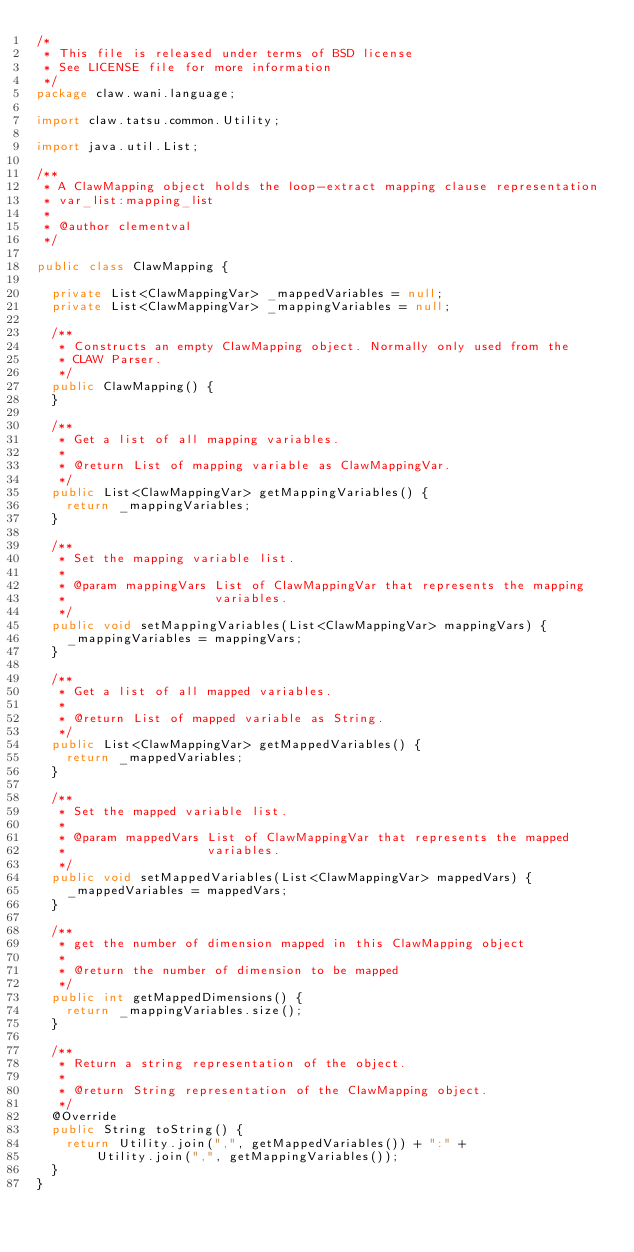Convert code to text. <code><loc_0><loc_0><loc_500><loc_500><_Java_>/*
 * This file is released under terms of BSD license
 * See LICENSE file for more information
 */
package claw.wani.language;

import claw.tatsu.common.Utility;

import java.util.List;

/**
 * A ClawMapping object holds the loop-extract mapping clause representation
 * var_list:mapping_list
 *
 * @author clementval
 */

public class ClawMapping {

  private List<ClawMappingVar> _mappedVariables = null;
  private List<ClawMappingVar> _mappingVariables = null;

  /**
   * Constructs an empty ClawMapping object. Normally only used from the
   * CLAW Parser.
   */
  public ClawMapping() {
  }

  /**
   * Get a list of all mapping variables.
   *
   * @return List of mapping variable as ClawMappingVar.
   */
  public List<ClawMappingVar> getMappingVariables() {
    return _mappingVariables;
  }

  /**
   * Set the mapping variable list.
   *
   * @param mappingVars List of ClawMappingVar that represents the mapping
   *                    variables.
   */
  public void setMappingVariables(List<ClawMappingVar> mappingVars) {
    _mappingVariables = mappingVars;
  }

  /**
   * Get a list of all mapped variables.
   *
   * @return List of mapped variable as String.
   */
  public List<ClawMappingVar> getMappedVariables() {
    return _mappedVariables;
  }

  /**
   * Set the mapped variable list.
   *
   * @param mappedVars List of ClawMappingVar that represents the mapped
   *                   variables.
   */
  public void setMappedVariables(List<ClawMappingVar> mappedVars) {
    _mappedVariables = mappedVars;
  }

  /**
   * get the number of dimension mapped in this ClawMapping object
   *
   * @return the number of dimension to be mapped
   */
  public int getMappedDimensions() {
    return _mappingVariables.size();
  }

  /**
   * Return a string representation of the object.
   *
   * @return String representation of the ClawMapping object.
   */
  @Override
  public String toString() {
    return Utility.join(",", getMappedVariables()) + ":" +
        Utility.join(",", getMappingVariables());
  }
}
</code> 